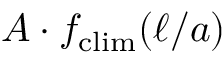<formula> <loc_0><loc_0><loc_500><loc_500>A \cdot f _ { c l i m } ( \ell / a )</formula> 